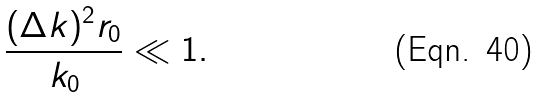Convert formula to latex. <formula><loc_0><loc_0><loc_500><loc_500>\frac { ( \Delta k ) ^ { 2 } r _ { 0 } } { k _ { 0 } } \ll 1 .</formula> 